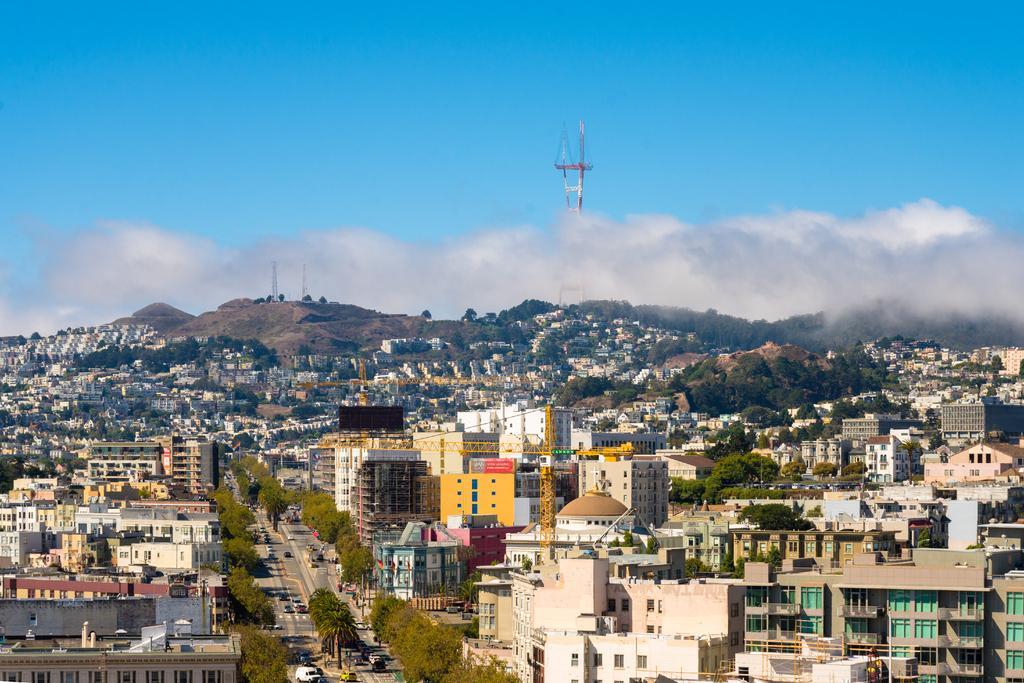Can you describe this image briefly? In this picture we can see there are buildings, trees, cranes and some vehicles on the road. Behind the buildings there is a tower, hills and the cloudy sky. 